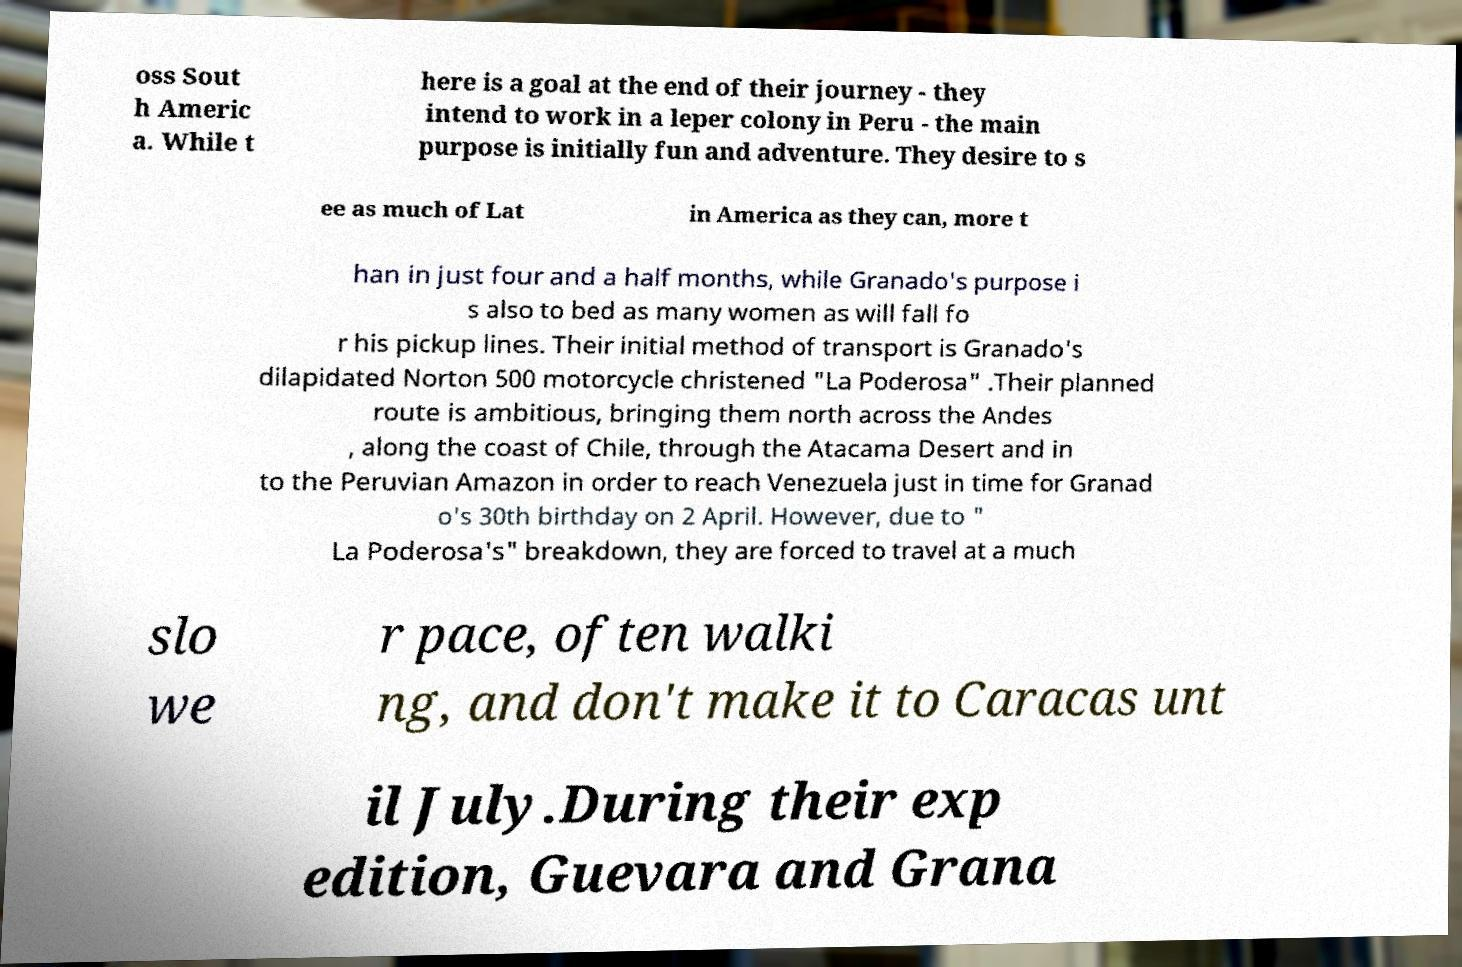Please read and relay the text visible in this image. What does it say? oss Sout h Americ a. While t here is a goal at the end of their journey - they intend to work in a leper colony in Peru - the main purpose is initially fun and adventure. They desire to s ee as much of Lat in America as they can, more t han in just four and a half months, while Granado's purpose i s also to bed as many women as will fall fo r his pickup lines. Their initial method of transport is Granado's dilapidated Norton 500 motorcycle christened "La Poderosa" .Their planned route is ambitious, bringing them north across the Andes , along the coast of Chile, through the Atacama Desert and in to the Peruvian Amazon in order to reach Venezuela just in time for Granad o's 30th birthday on 2 April. However, due to " La Poderosa's" breakdown, they are forced to travel at a much slo we r pace, often walki ng, and don't make it to Caracas unt il July.During their exp edition, Guevara and Grana 